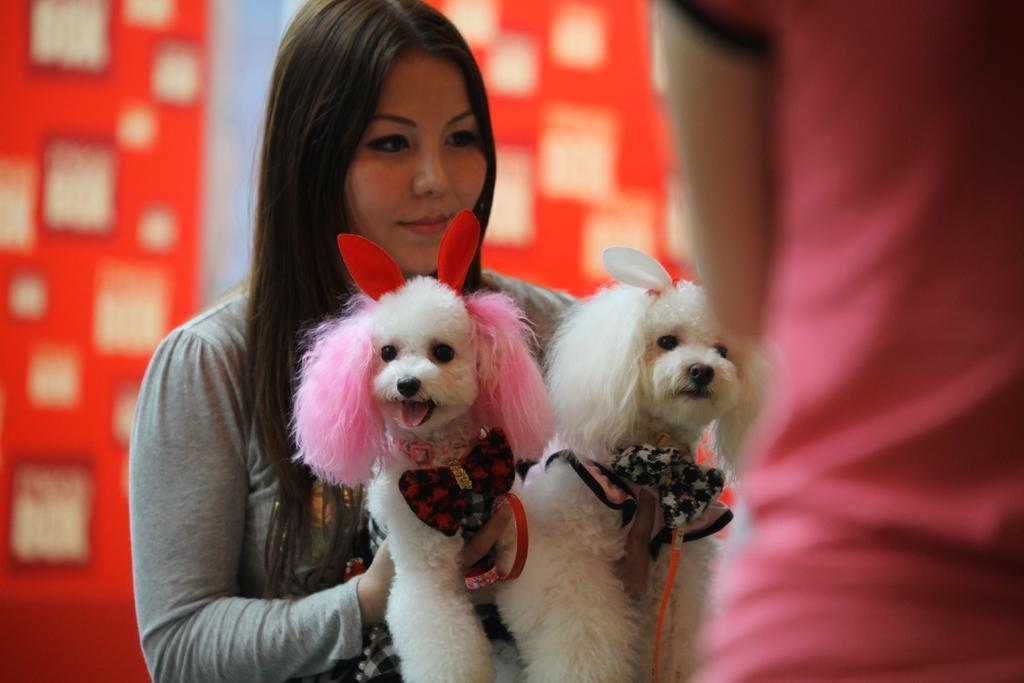What is the main subject of the image? The main subject of the image is a woman. What is the woman doing in the image? The woman is standing and holding two dogs. What is the woman wearing in the image? The woman is wearing a grey color dress. Can you describe one of the dogs in the image? One of the dogs has red horns. What type of wax can be seen melting in the image? There is no wax present in the image. What is the pot used for in the image? There is no pot present in the image. Where is the cannon located in the image? There is no cannon present in the image. 